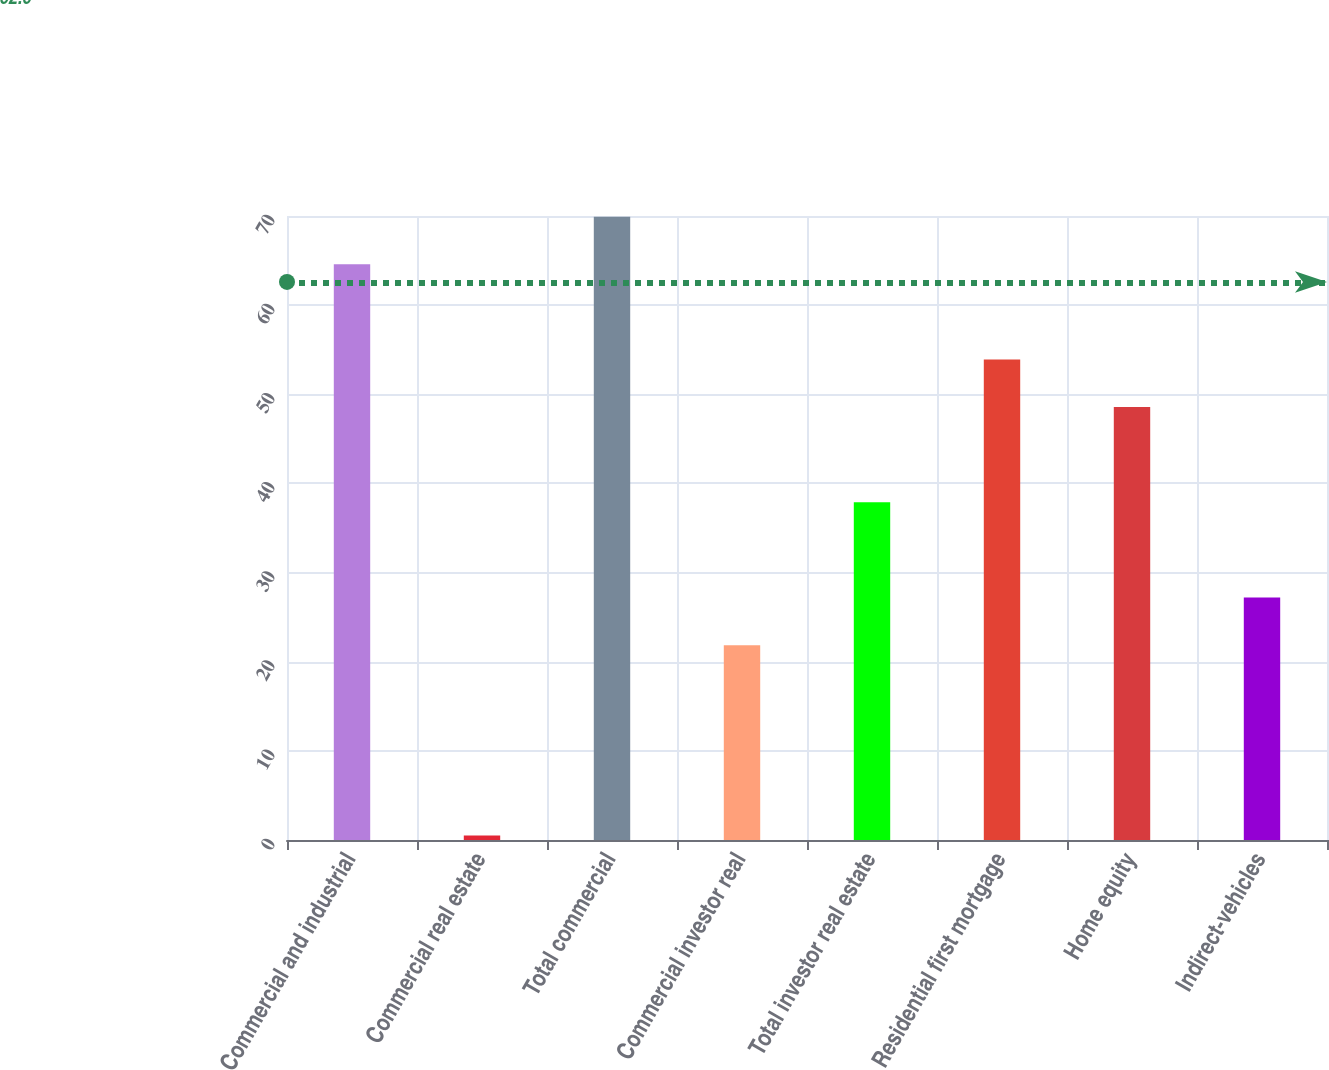Convert chart to OTSL. <chart><loc_0><loc_0><loc_500><loc_500><bar_chart><fcel>Commercial and industrial<fcel>Commercial real estate<fcel>Total commercial<fcel>Commercial investor real<fcel>Total investor real estate<fcel>Residential first mortgage<fcel>Home equity<fcel>Indirect-vehicles<nl><fcel>64.58<fcel>0.5<fcel>69.92<fcel>21.86<fcel>37.88<fcel>53.9<fcel>48.56<fcel>27.2<nl></chart> 